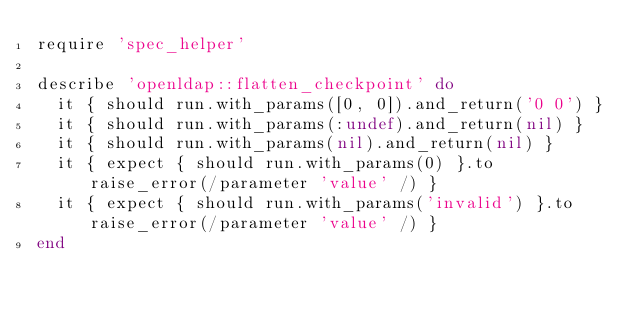Convert code to text. <code><loc_0><loc_0><loc_500><loc_500><_Ruby_>require 'spec_helper'

describe 'openldap::flatten_checkpoint' do
  it { should run.with_params([0, 0]).and_return('0 0') }
  it { should run.with_params(:undef).and_return(nil) }
  it { should run.with_params(nil).and_return(nil) }
  it { expect { should run.with_params(0) }.to raise_error(/parameter 'value' /) }
  it { expect { should run.with_params('invalid') }.to raise_error(/parameter 'value' /) }
end
</code> 